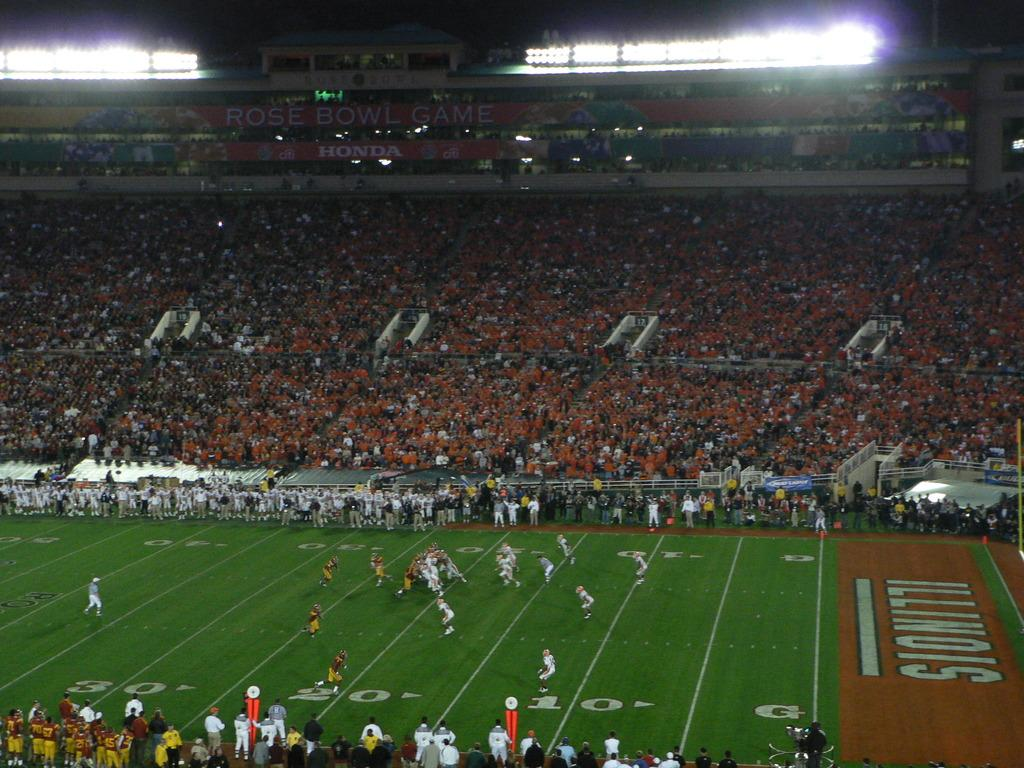<image>
Present a compact description of the photo's key features. College Football game presented by the Illinois home team. 